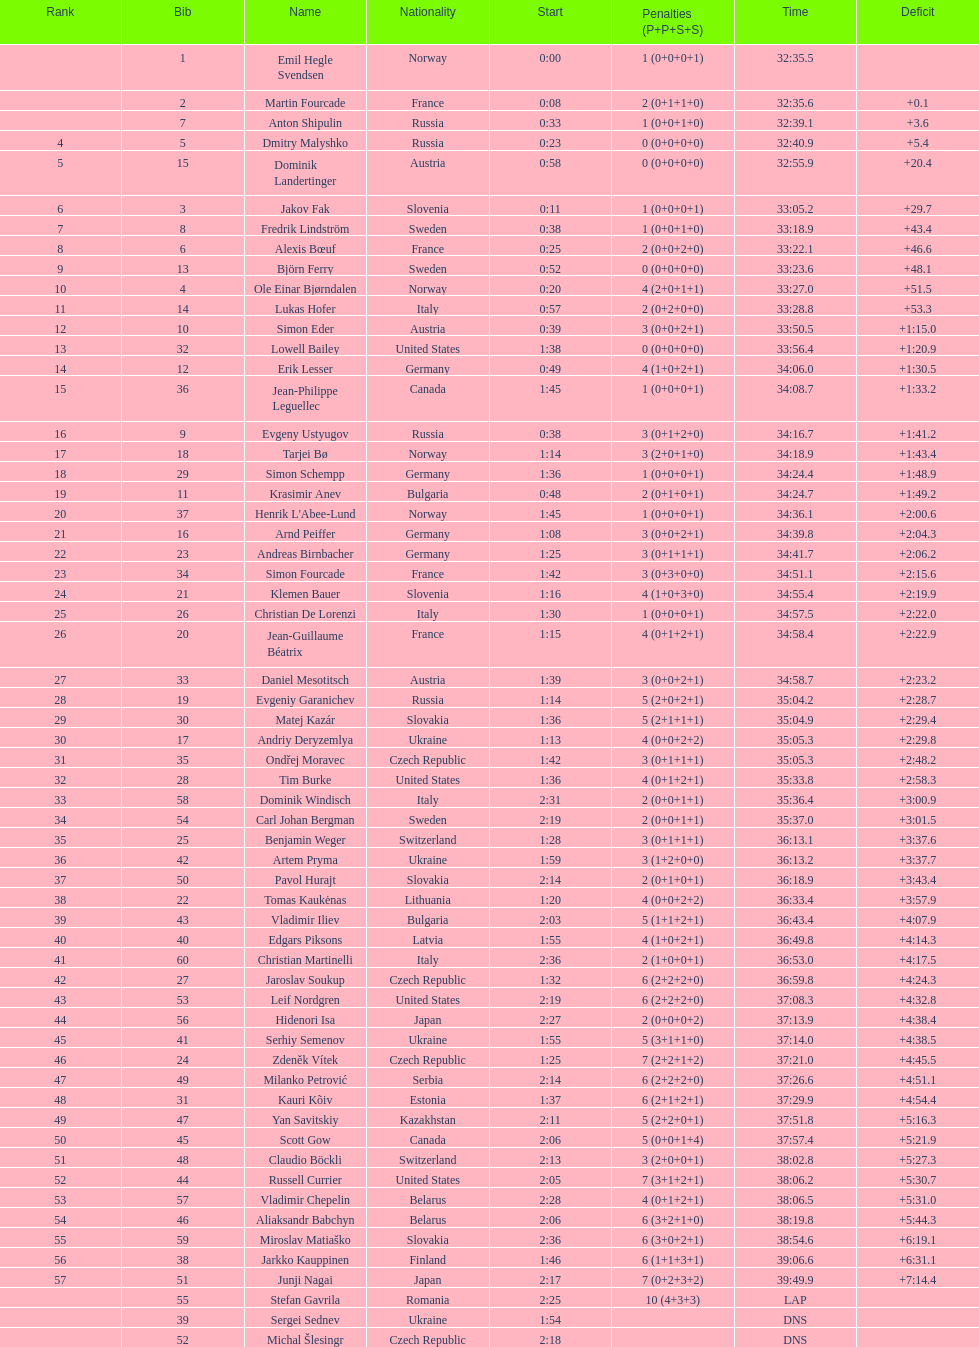How many united states competitors did not win medals? 4. 